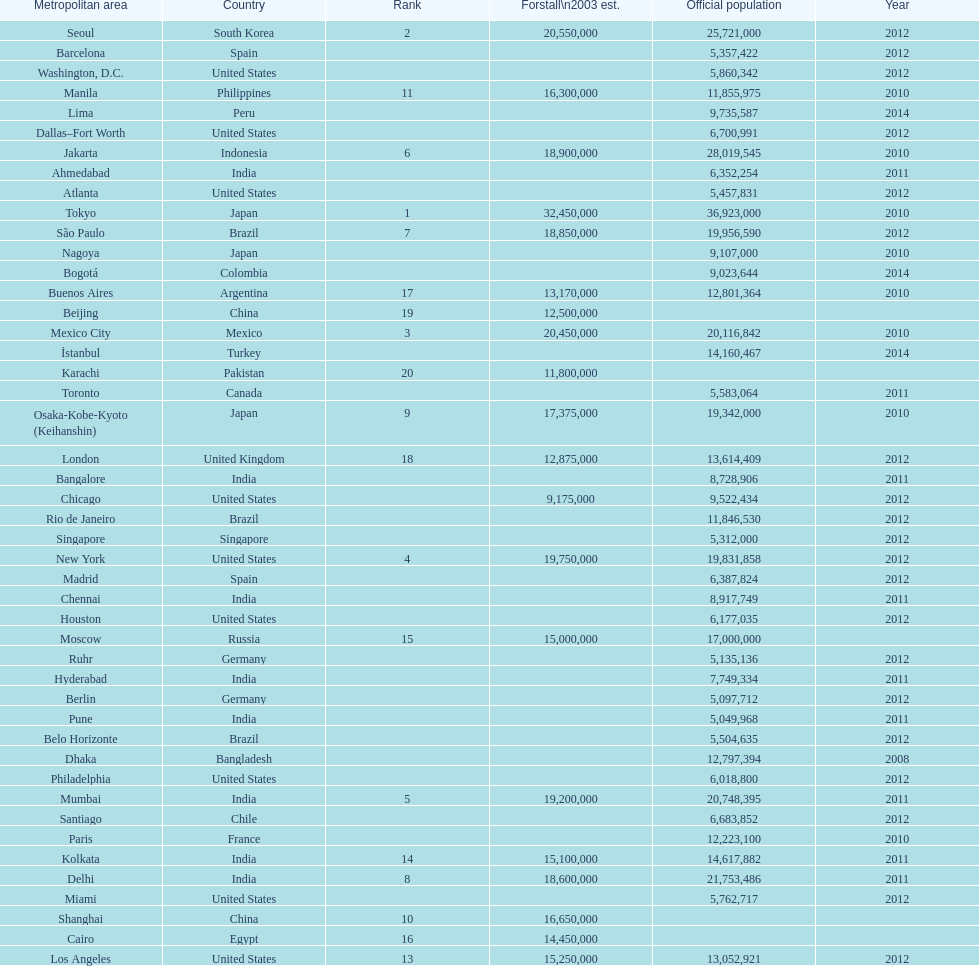Which areas had a population of more than 10,000,000 but less than 20,000,000? Buenos Aires, Dhaka, İstanbul, Kolkata, London, Los Angeles, Manila, Moscow, New York, Osaka-Kobe-Kyoto (Keihanshin), Paris, Rio de Janeiro, São Paulo. 